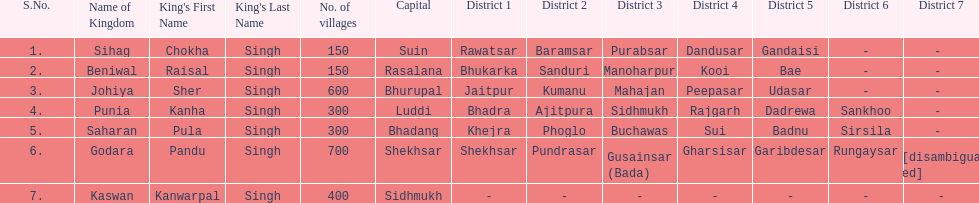What are the number of villages johiya has according to this chart? 600. 